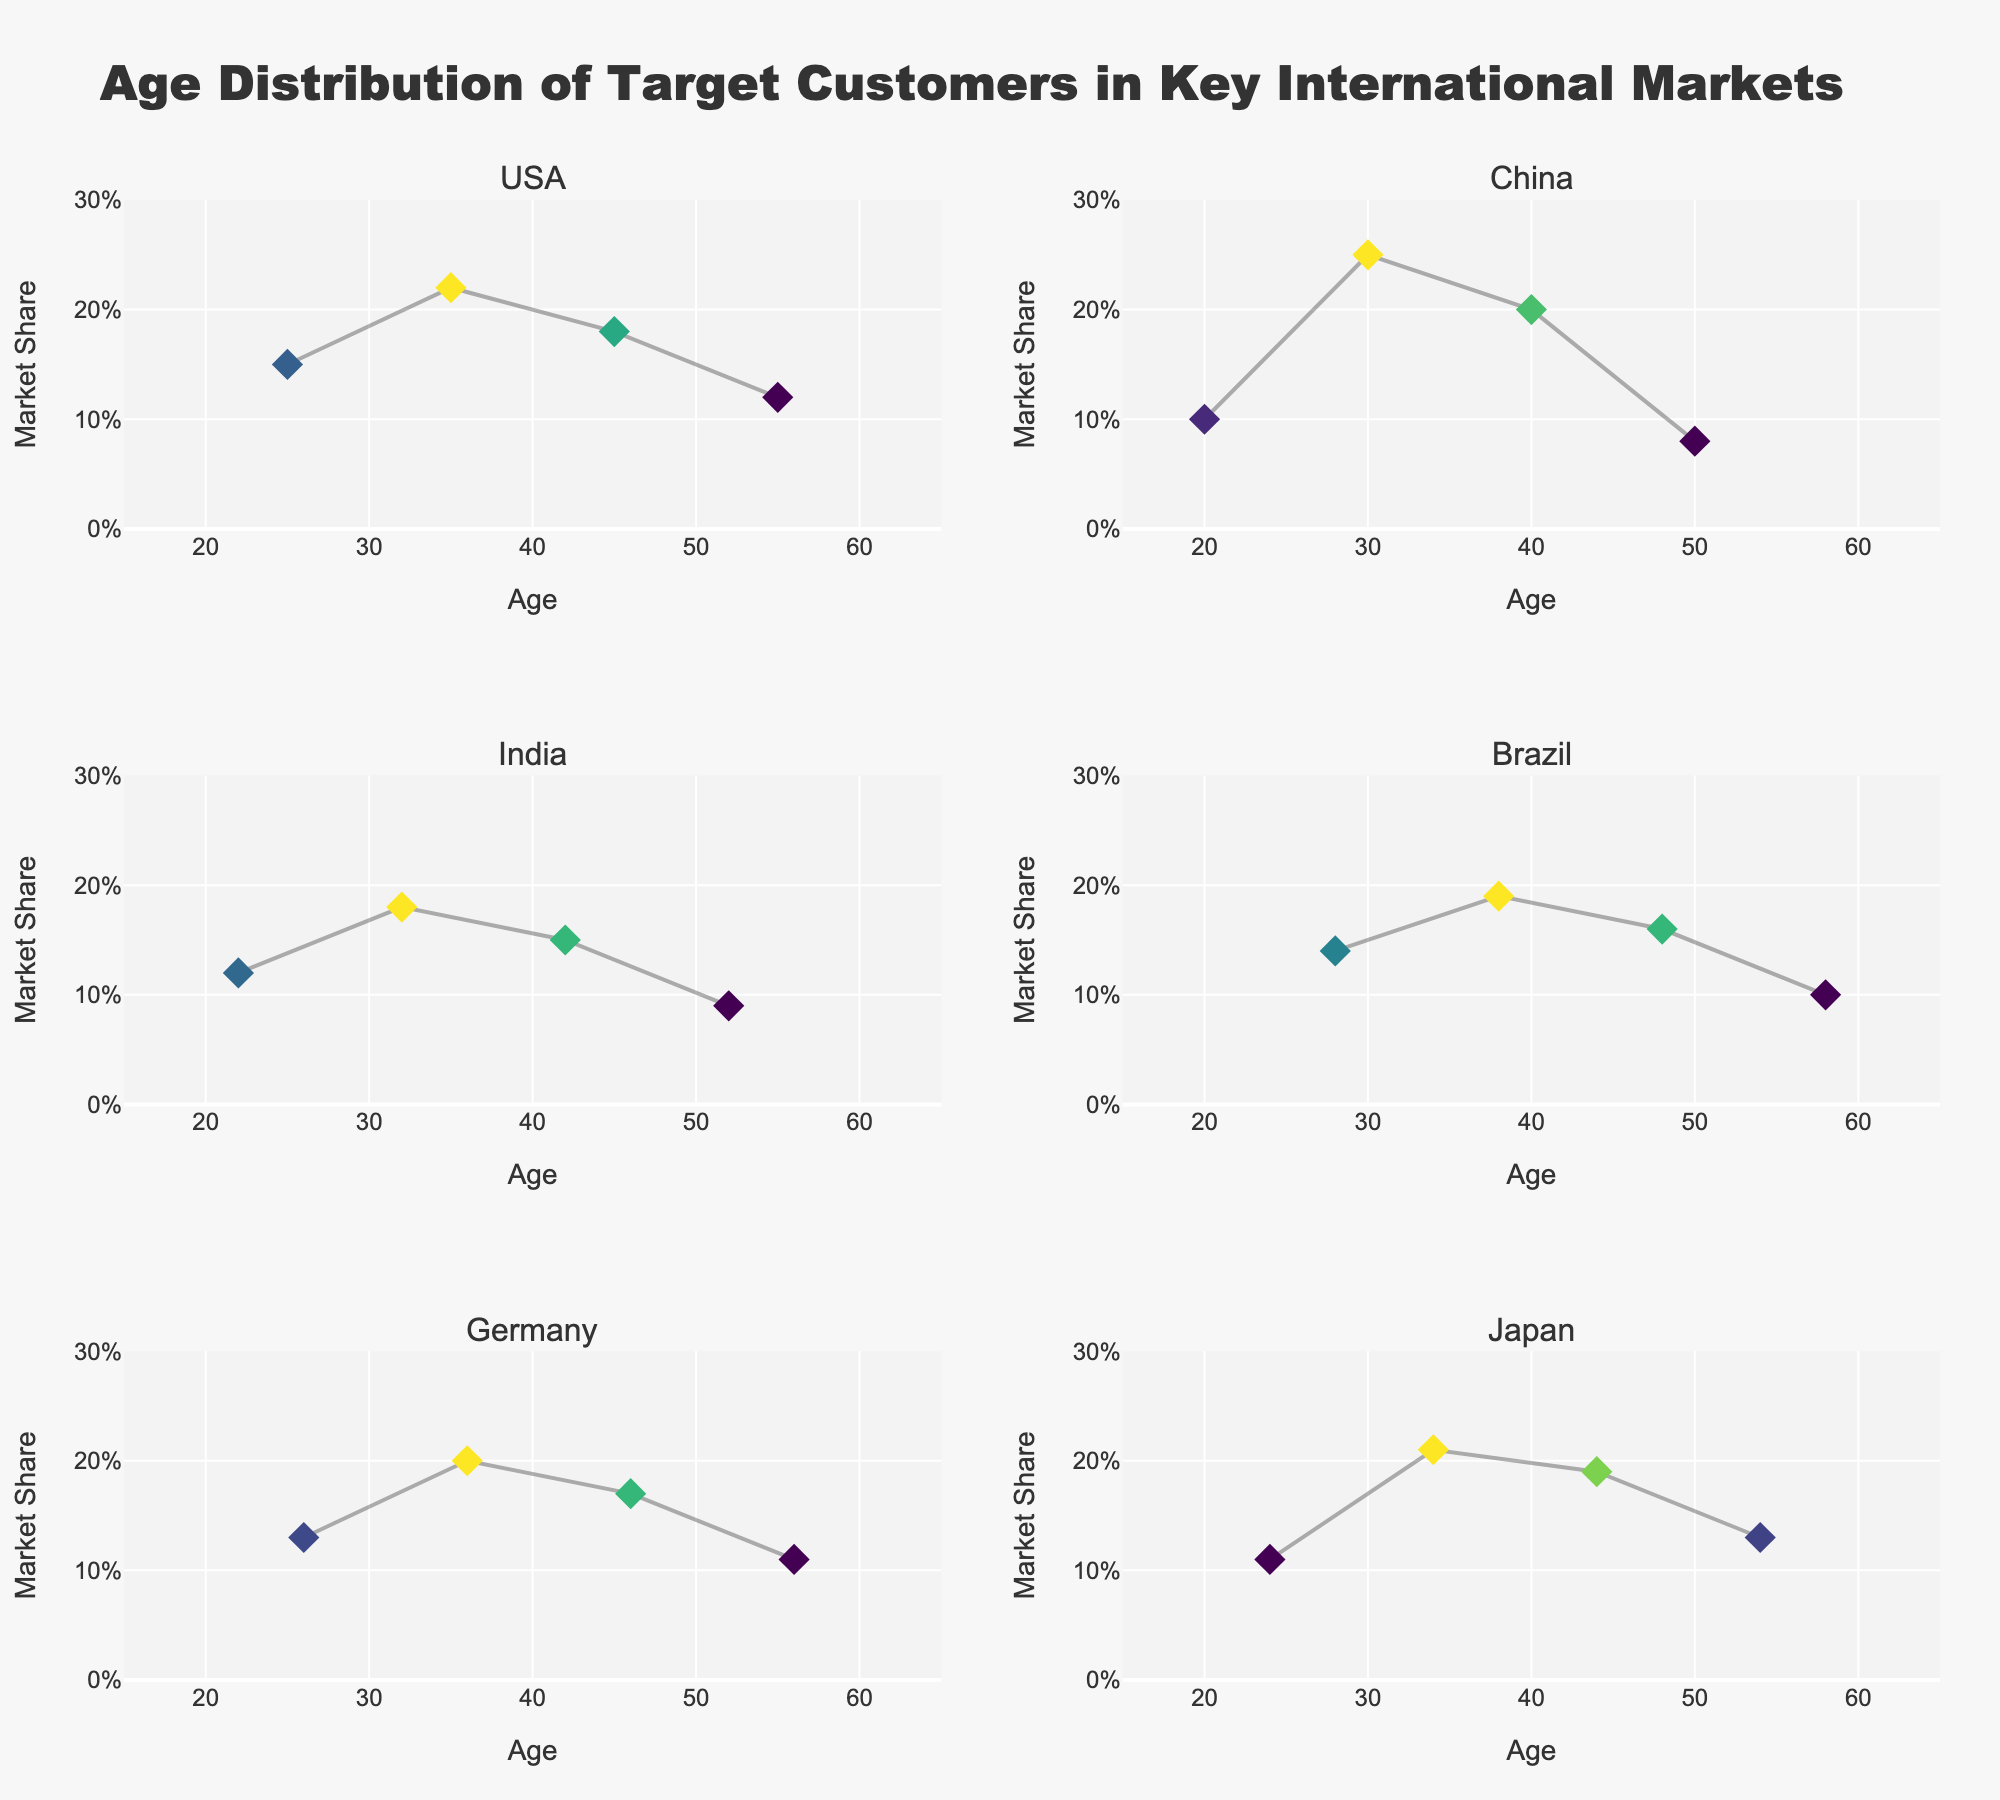What is the main title of the figure? The main title is displayed at the top of the figure and summarizes the visual data being presented.
Answer: Age Distribution of Target Customers in Key International Markets Which country has the highest market share at age 30? Looking at the marker positions, China shows the highest market share value at age 30.
Answer: China How does the market share trend with increasing age for the USA? The USA's market share increases initially, peaks at age 35, and then gradually declines.
Answer: Increases, peaks at 35, then declines In which country is the target customer market share highest at age 40? Find the subplot for each country and look at the marker for age 40. China has the highest market share at this age.
Answer: China Which country has the widest range of market share values across all ages? By comparing the vertical spreads of the scatter plots in each subplot, China shows the widest range of market share values from 0.08 to 0.25.
Answer: China What's the average market share for India across the ages indicated? Adding the market share values for India: 0.12 + 0.18 + 0.15 + 0.09, the total is 0.54. Dividing by the number of values (4), the average is 0.135.
Answer: 0.135 In which country does market share decline consistently with age? Identify the subplots that show a consistent downward trend in market share with increasing age. China has a noticeable consistent decline from ages 30 to 50.
Answer: China Which two countries show the most similar trend in market share distribution across ages? Comparing the patterns in marker and line progression, Germany and Japan both show steady increases, peaking in the 30s or 40s, then gradual declines.
Answer: Germany and Japan At what age does Brazil reach its peak market share? Look at the Brazil subplot and identify the age where the market share marker is highest; it peaks at age 38.
Answer: 38 Is there a country where the market share at age 50 is higher than at age 40? Compare the market share values for ages 40 and 50 in each subplot; none of the countries meets this criterion.
Answer: No 